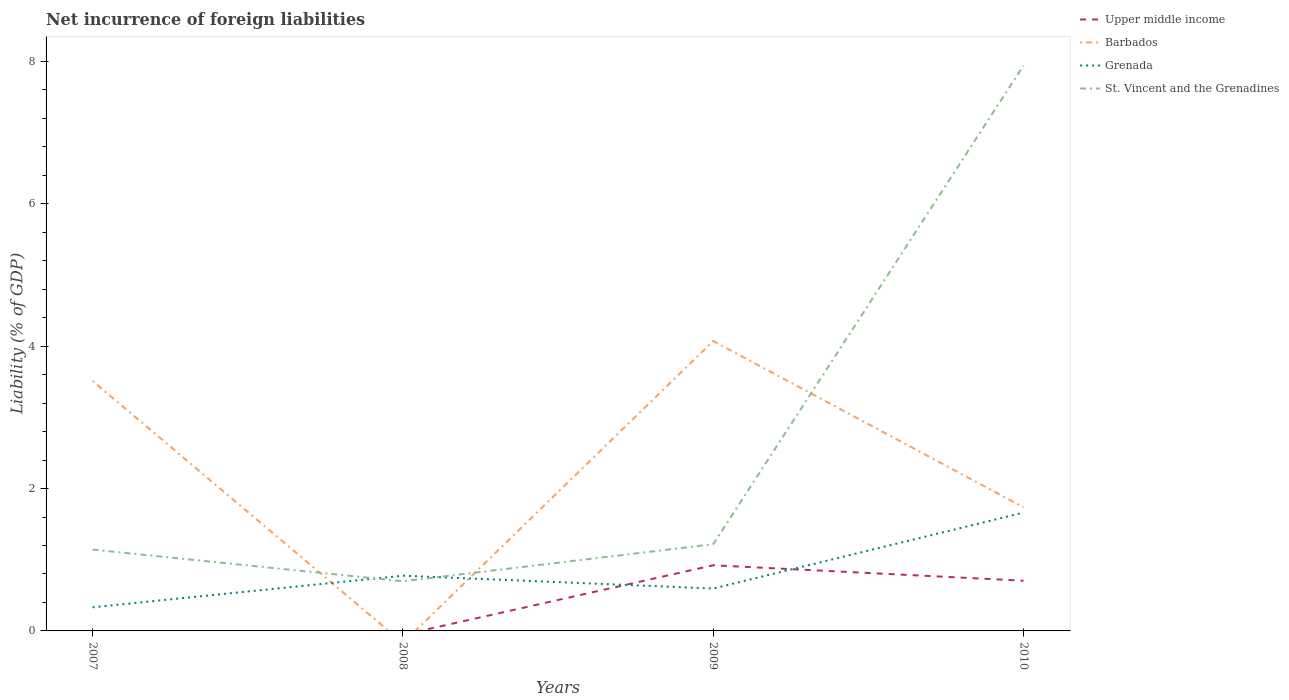How many different coloured lines are there?
Your answer should be compact. 4. Does the line corresponding to Barbados intersect with the line corresponding to Grenada?
Your response must be concise. Yes. Across all years, what is the maximum net incurrence of foreign liabilities in Grenada?
Your answer should be very brief. 0.33. What is the total net incurrence of foreign liabilities in Barbados in the graph?
Give a very brief answer. 1.77. What is the difference between the highest and the second highest net incurrence of foreign liabilities in Barbados?
Your answer should be compact. 4.07. Is the net incurrence of foreign liabilities in Barbados strictly greater than the net incurrence of foreign liabilities in Grenada over the years?
Offer a very short reply. No. How many years are there in the graph?
Your answer should be very brief. 4. Are the values on the major ticks of Y-axis written in scientific E-notation?
Your answer should be compact. No. Does the graph contain any zero values?
Provide a short and direct response. Yes. How many legend labels are there?
Ensure brevity in your answer.  4. How are the legend labels stacked?
Your response must be concise. Vertical. What is the title of the graph?
Provide a short and direct response. Net incurrence of foreign liabilities. Does "China" appear as one of the legend labels in the graph?
Your answer should be very brief. No. What is the label or title of the X-axis?
Offer a terse response. Years. What is the label or title of the Y-axis?
Offer a very short reply. Liability (% of GDP). What is the Liability (% of GDP) in Barbados in 2007?
Your response must be concise. 3.51. What is the Liability (% of GDP) in Grenada in 2007?
Give a very brief answer. 0.33. What is the Liability (% of GDP) in St. Vincent and the Grenadines in 2007?
Make the answer very short. 1.14. What is the Liability (% of GDP) of Upper middle income in 2008?
Make the answer very short. 0. What is the Liability (% of GDP) of Grenada in 2008?
Your response must be concise. 0.78. What is the Liability (% of GDP) of St. Vincent and the Grenadines in 2008?
Keep it short and to the point. 0.7. What is the Liability (% of GDP) of Upper middle income in 2009?
Keep it short and to the point. 0.92. What is the Liability (% of GDP) in Barbados in 2009?
Offer a terse response. 4.07. What is the Liability (% of GDP) of Grenada in 2009?
Your response must be concise. 0.6. What is the Liability (% of GDP) of St. Vincent and the Grenadines in 2009?
Your answer should be very brief. 1.22. What is the Liability (% of GDP) of Upper middle income in 2010?
Keep it short and to the point. 0.71. What is the Liability (% of GDP) in Barbados in 2010?
Ensure brevity in your answer.  1.74. What is the Liability (% of GDP) of Grenada in 2010?
Offer a terse response. 1.66. What is the Liability (% of GDP) in St. Vincent and the Grenadines in 2010?
Give a very brief answer. 7.94. Across all years, what is the maximum Liability (% of GDP) of Upper middle income?
Provide a succinct answer. 0.92. Across all years, what is the maximum Liability (% of GDP) of Barbados?
Make the answer very short. 4.07. Across all years, what is the maximum Liability (% of GDP) of Grenada?
Give a very brief answer. 1.66. Across all years, what is the maximum Liability (% of GDP) in St. Vincent and the Grenadines?
Ensure brevity in your answer.  7.94. Across all years, what is the minimum Liability (% of GDP) of Barbados?
Your answer should be very brief. 0. Across all years, what is the minimum Liability (% of GDP) in Grenada?
Keep it short and to the point. 0.33. Across all years, what is the minimum Liability (% of GDP) of St. Vincent and the Grenadines?
Give a very brief answer. 0.7. What is the total Liability (% of GDP) of Upper middle income in the graph?
Keep it short and to the point. 1.63. What is the total Liability (% of GDP) in Barbados in the graph?
Keep it short and to the point. 9.32. What is the total Liability (% of GDP) in Grenada in the graph?
Ensure brevity in your answer.  3.37. What is the total Liability (% of GDP) of St. Vincent and the Grenadines in the graph?
Offer a very short reply. 11. What is the difference between the Liability (% of GDP) of Grenada in 2007 and that in 2008?
Provide a short and direct response. -0.44. What is the difference between the Liability (% of GDP) of St. Vincent and the Grenadines in 2007 and that in 2008?
Provide a short and direct response. 0.45. What is the difference between the Liability (% of GDP) of Barbados in 2007 and that in 2009?
Give a very brief answer. -0.56. What is the difference between the Liability (% of GDP) in Grenada in 2007 and that in 2009?
Your answer should be very brief. -0.26. What is the difference between the Liability (% of GDP) in St. Vincent and the Grenadines in 2007 and that in 2009?
Your response must be concise. -0.08. What is the difference between the Liability (% of GDP) of Barbados in 2007 and that in 2010?
Provide a succinct answer. 1.77. What is the difference between the Liability (% of GDP) in Grenada in 2007 and that in 2010?
Keep it short and to the point. -1.33. What is the difference between the Liability (% of GDP) in St. Vincent and the Grenadines in 2007 and that in 2010?
Make the answer very short. -6.8. What is the difference between the Liability (% of GDP) in Grenada in 2008 and that in 2009?
Your response must be concise. 0.18. What is the difference between the Liability (% of GDP) of St. Vincent and the Grenadines in 2008 and that in 2009?
Provide a succinct answer. -0.52. What is the difference between the Liability (% of GDP) in Grenada in 2008 and that in 2010?
Your answer should be very brief. -0.89. What is the difference between the Liability (% of GDP) of St. Vincent and the Grenadines in 2008 and that in 2010?
Offer a terse response. -7.25. What is the difference between the Liability (% of GDP) in Upper middle income in 2009 and that in 2010?
Ensure brevity in your answer.  0.22. What is the difference between the Liability (% of GDP) of Barbados in 2009 and that in 2010?
Your answer should be very brief. 2.33. What is the difference between the Liability (% of GDP) of Grenada in 2009 and that in 2010?
Keep it short and to the point. -1.07. What is the difference between the Liability (% of GDP) in St. Vincent and the Grenadines in 2009 and that in 2010?
Ensure brevity in your answer.  -6.72. What is the difference between the Liability (% of GDP) in Barbados in 2007 and the Liability (% of GDP) in Grenada in 2008?
Your answer should be very brief. 2.74. What is the difference between the Liability (% of GDP) in Barbados in 2007 and the Liability (% of GDP) in St. Vincent and the Grenadines in 2008?
Make the answer very short. 2.81. What is the difference between the Liability (% of GDP) of Grenada in 2007 and the Liability (% of GDP) of St. Vincent and the Grenadines in 2008?
Provide a succinct answer. -0.37. What is the difference between the Liability (% of GDP) in Barbados in 2007 and the Liability (% of GDP) in Grenada in 2009?
Your answer should be very brief. 2.92. What is the difference between the Liability (% of GDP) in Barbados in 2007 and the Liability (% of GDP) in St. Vincent and the Grenadines in 2009?
Ensure brevity in your answer.  2.29. What is the difference between the Liability (% of GDP) in Grenada in 2007 and the Liability (% of GDP) in St. Vincent and the Grenadines in 2009?
Keep it short and to the point. -0.89. What is the difference between the Liability (% of GDP) of Barbados in 2007 and the Liability (% of GDP) of Grenada in 2010?
Offer a terse response. 1.85. What is the difference between the Liability (% of GDP) of Barbados in 2007 and the Liability (% of GDP) of St. Vincent and the Grenadines in 2010?
Your response must be concise. -4.43. What is the difference between the Liability (% of GDP) in Grenada in 2007 and the Liability (% of GDP) in St. Vincent and the Grenadines in 2010?
Provide a succinct answer. -7.61. What is the difference between the Liability (% of GDP) in Grenada in 2008 and the Liability (% of GDP) in St. Vincent and the Grenadines in 2009?
Your response must be concise. -0.44. What is the difference between the Liability (% of GDP) in Grenada in 2008 and the Liability (% of GDP) in St. Vincent and the Grenadines in 2010?
Offer a terse response. -7.17. What is the difference between the Liability (% of GDP) in Upper middle income in 2009 and the Liability (% of GDP) in Barbados in 2010?
Your answer should be compact. -0.81. What is the difference between the Liability (% of GDP) in Upper middle income in 2009 and the Liability (% of GDP) in Grenada in 2010?
Make the answer very short. -0.74. What is the difference between the Liability (% of GDP) of Upper middle income in 2009 and the Liability (% of GDP) of St. Vincent and the Grenadines in 2010?
Provide a short and direct response. -7.02. What is the difference between the Liability (% of GDP) in Barbados in 2009 and the Liability (% of GDP) in Grenada in 2010?
Provide a short and direct response. 2.41. What is the difference between the Liability (% of GDP) of Barbados in 2009 and the Liability (% of GDP) of St. Vincent and the Grenadines in 2010?
Your answer should be compact. -3.87. What is the difference between the Liability (% of GDP) in Grenada in 2009 and the Liability (% of GDP) in St. Vincent and the Grenadines in 2010?
Your answer should be very brief. -7.35. What is the average Liability (% of GDP) of Upper middle income per year?
Offer a terse response. 0.41. What is the average Liability (% of GDP) in Barbados per year?
Offer a very short reply. 2.33. What is the average Liability (% of GDP) in Grenada per year?
Give a very brief answer. 0.84. What is the average Liability (% of GDP) of St. Vincent and the Grenadines per year?
Provide a short and direct response. 2.75. In the year 2007, what is the difference between the Liability (% of GDP) of Barbados and Liability (% of GDP) of Grenada?
Make the answer very short. 3.18. In the year 2007, what is the difference between the Liability (% of GDP) in Barbados and Liability (% of GDP) in St. Vincent and the Grenadines?
Keep it short and to the point. 2.37. In the year 2007, what is the difference between the Liability (% of GDP) in Grenada and Liability (% of GDP) in St. Vincent and the Grenadines?
Make the answer very short. -0.81. In the year 2008, what is the difference between the Liability (% of GDP) in Grenada and Liability (% of GDP) in St. Vincent and the Grenadines?
Keep it short and to the point. 0.08. In the year 2009, what is the difference between the Liability (% of GDP) in Upper middle income and Liability (% of GDP) in Barbados?
Offer a very short reply. -3.15. In the year 2009, what is the difference between the Liability (% of GDP) in Upper middle income and Liability (% of GDP) in Grenada?
Offer a very short reply. 0.33. In the year 2009, what is the difference between the Liability (% of GDP) of Upper middle income and Liability (% of GDP) of St. Vincent and the Grenadines?
Make the answer very short. -0.3. In the year 2009, what is the difference between the Liability (% of GDP) of Barbados and Liability (% of GDP) of Grenada?
Your response must be concise. 3.48. In the year 2009, what is the difference between the Liability (% of GDP) in Barbados and Liability (% of GDP) in St. Vincent and the Grenadines?
Your answer should be very brief. 2.85. In the year 2009, what is the difference between the Liability (% of GDP) of Grenada and Liability (% of GDP) of St. Vincent and the Grenadines?
Provide a short and direct response. -0.62. In the year 2010, what is the difference between the Liability (% of GDP) in Upper middle income and Liability (% of GDP) in Barbados?
Your response must be concise. -1.03. In the year 2010, what is the difference between the Liability (% of GDP) in Upper middle income and Liability (% of GDP) in Grenada?
Your response must be concise. -0.96. In the year 2010, what is the difference between the Liability (% of GDP) in Upper middle income and Liability (% of GDP) in St. Vincent and the Grenadines?
Ensure brevity in your answer.  -7.24. In the year 2010, what is the difference between the Liability (% of GDP) in Barbados and Liability (% of GDP) in Grenada?
Ensure brevity in your answer.  0.07. In the year 2010, what is the difference between the Liability (% of GDP) of Barbados and Liability (% of GDP) of St. Vincent and the Grenadines?
Make the answer very short. -6.21. In the year 2010, what is the difference between the Liability (% of GDP) in Grenada and Liability (% of GDP) in St. Vincent and the Grenadines?
Give a very brief answer. -6.28. What is the ratio of the Liability (% of GDP) of Grenada in 2007 to that in 2008?
Your response must be concise. 0.43. What is the ratio of the Liability (% of GDP) in St. Vincent and the Grenadines in 2007 to that in 2008?
Your response must be concise. 1.64. What is the ratio of the Liability (% of GDP) of Barbados in 2007 to that in 2009?
Provide a short and direct response. 0.86. What is the ratio of the Liability (% of GDP) of Grenada in 2007 to that in 2009?
Give a very brief answer. 0.56. What is the ratio of the Liability (% of GDP) in St. Vincent and the Grenadines in 2007 to that in 2009?
Keep it short and to the point. 0.94. What is the ratio of the Liability (% of GDP) of Barbados in 2007 to that in 2010?
Your response must be concise. 2.02. What is the ratio of the Liability (% of GDP) of Grenada in 2007 to that in 2010?
Offer a very short reply. 0.2. What is the ratio of the Liability (% of GDP) in St. Vincent and the Grenadines in 2007 to that in 2010?
Give a very brief answer. 0.14. What is the ratio of the Liability (% of GDP) in Grenada in 2008 to that in 2009?
Your answer should be very brief. 1.3. What is the ratio of the Liability (% of GDP) in St. Vincent and the Grenadines in 2008 to that in 2009?
Your answer should be compact. 0.57. What is the ratio of the Liability (% of GDP) in Grenada in 2008 to that in 2010?
Your response must be concise. 0.47. What is the ratio of the Liability (% of GDP) of St. Vincent and the Grenadines in 2008 to that in 2010?
Offer a terse response. 0.09. What is the ratio of the Liability (% of GDP) of Upper middle income in 2009 to that in 2010?
Ensure brevity in your answer.  1.31. What is the ratio of the Liability (% of GDP) of Barbados in 2009 to that in 2010?
Your answer should be compact. 2.34. What is the ratio of the Liability (% of GDP) of Grenada in 2009 to that in 2010?
Make the answer very short. 0.36. What is the ratio of the Liability (% of GDP) of St. Vincent and the Grenadines in 2009 to that in 2010?
Ensure brevity in your answer.  0.15. What is the difference between the highest and the second highest Liability (% of GDP) in Barbados?
Ensure brevity in your answer.  0.56. What is the difference between the highest and the second highest Liability (% of GDP) of Grenada?
Provide a succinct answer. 0.89. What is the difference between the highest and the second highest Liability (% of GDP) in St. Vincent and the Grenadines?
Your answer should be very brief. 6.72. What is the difference between the highest and the lowest Liability (% of GDP) in Upper middle income?
Provide a succinct answer. 0.92. What is the difference between the highest and the lowest Liability (% of GDP) of Barbados?
Your answer should be compact. 4.07. What is the difference between the highest and the lowest Liability (% of GDP) of Grenada?
Provide a short and direct response. 1.33. What is the difference between the highest and the lowest Liability (% of GDP) in St. Vincent and the Grenadines?
Your answer should be compact. 7.25. 